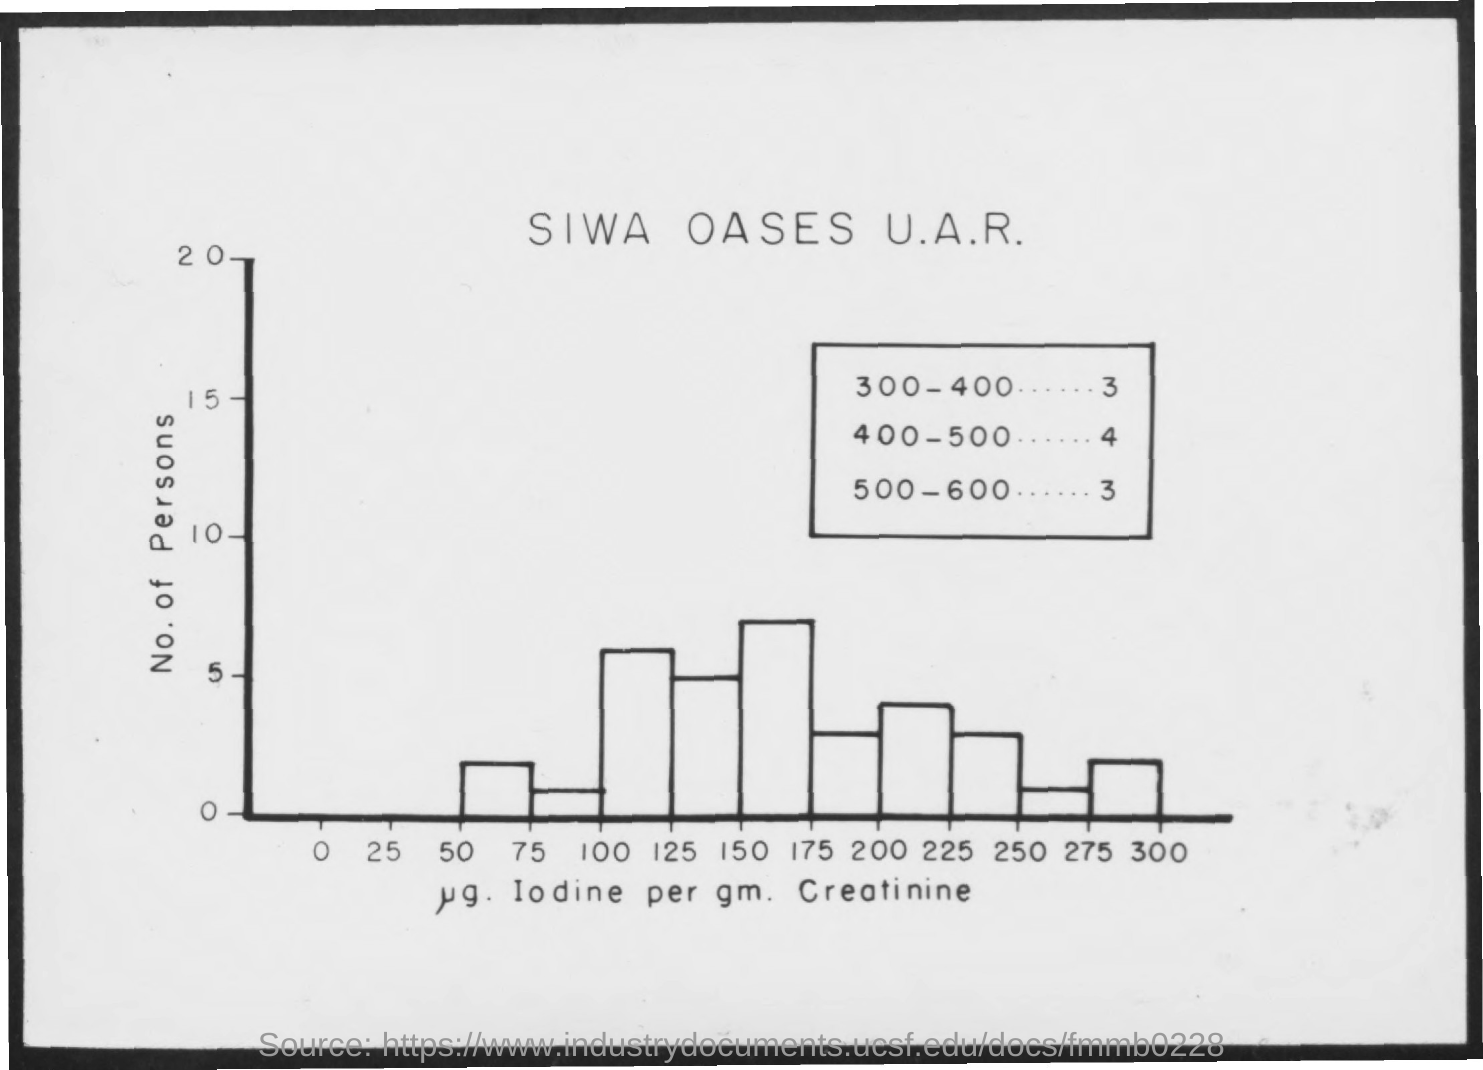What is plotted in the y-axis?
Give a very brief answer. No. of persons. 